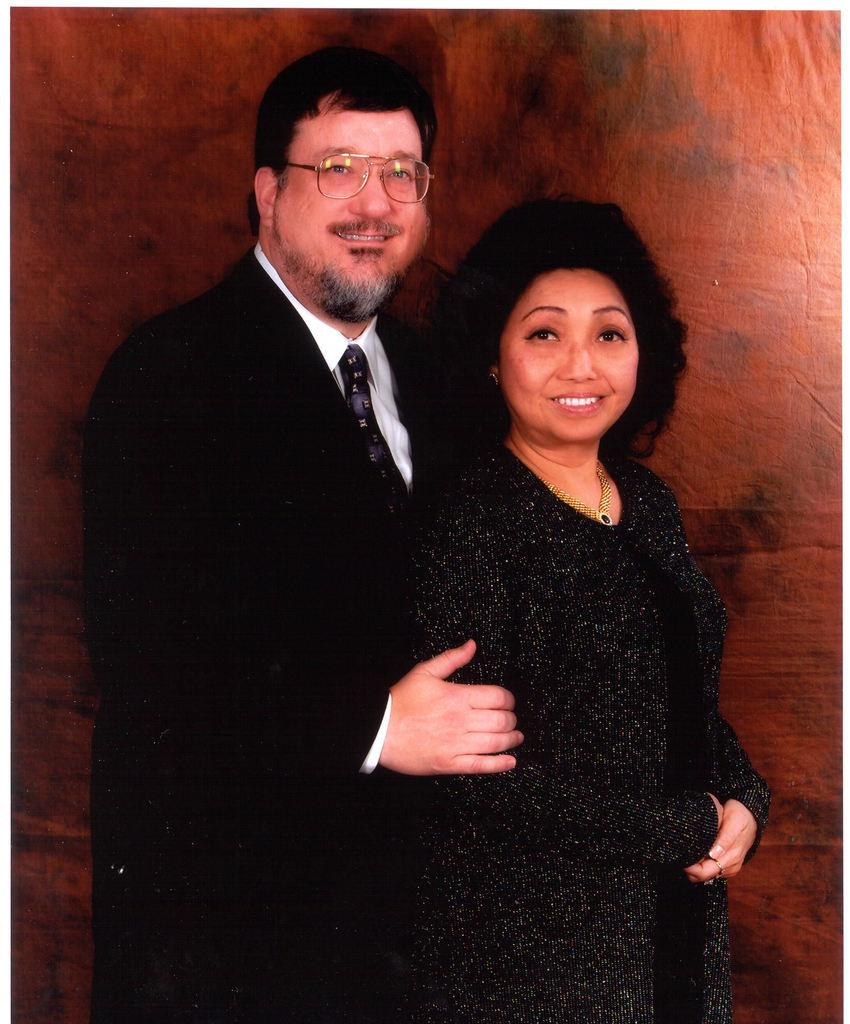What is the person in the image wearing? The person in the image is wearing a black suit. What is the facial expression of the person in the image? The person is smiling. What is the person in the image doing? The person is standing and holding a woman. What is the woman in the image wearing? The woman is wearing a black dress. What is the facial expression of the woman in the image? The woman is smiling. What is the woman in the image doing? The woman is standing and being held by the person. What is the color of the background in the image? The background of the image is brown in color. Can you see any rabbits hopping around in the image? No, there are no rabbits present in the image. What type of pan is being used by the person in the image? There is no pan visible in the image. 